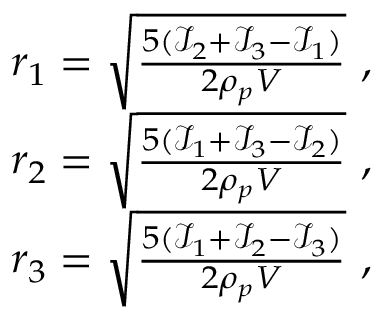<formula> <loc_0><loc_0><loc_500><loc_500>\begin{array} { r } { r _ { 1 } = \sqrt { \frac { 5 ( \mathcal { I } _ { 2 } + \mathcal { I } _ { 3 } - \mathcal { I } _ { 1 } ) } { 2 \rho _ { p } V } } \ , } \\ { r _ { 2 } = \sqrt { \frac { 5 ( \mathcal { I } _ { 1 } + \mathcal { I } _ { 3 } - \mathcal { I } _ { 2 } ) } { 2 \rho _ { p } V } } \ , } \\ { r _ { 3 } = \sqrt { \frac { 5 ( \mathcal { I } _ { 1 } + \mathcal { I } _ { 2 } - \mathcal { I } _ { 3 } ) } { 2 \rho _ { p } V } } \ , } \end{array}</formula> 